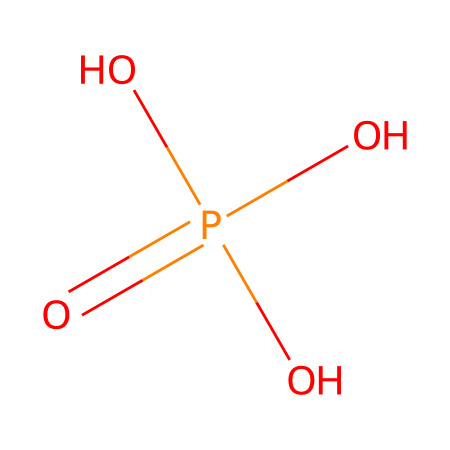What is the molecular formula of phosphoric acid? The SMILES representation shows the elements present in the structure: phosphorus (P) and oxygen (O), along with hydrogen (H). The counts are 1 phosphorus, 4 oxygen, and 3 hydrogen, leading to the formula H3PO4.
Answer: H3PO4 How many oxygen atoms are in this molecule? From the SMILES representation, we can count that there are four oxygen atoms connected to the phosphorus atom.
Answer: four What is the oxidation state of phosphorus in phosphoric acid? The oxidation state can be determined by assessing the bonds phosphorus forms in this molecule. Phosphorus is typically in the +5 oxidation state in phosphoric acid because it has bonded with four oxygen atoms.
Answer: +5 Which functional groups are present in phosphoric acid? Analyzing the structure shows that phosphoric acid contains hydroxyl (-OH) groups bonded to the phosphorus atom, identifying it as an alcohol and an acid, making it a polyprotic acid.
Answer: hydroxyl groups What type of chemical is phosphoric acid classified as? Phosphoric acid contains hydrogen, oxygen, and phosphorus and exhibits properties of an acid (as it can donate protons), specifically being categorized as a weak acid.
Answer: weak acid How many hydrogen atoms are directly bonded to the phosphorus atom? Examining the SMILES, we see that phosphoric acid has 3 hydrogen atoms directly bonded to three of the oxygen atoms, which indicates they are part of the hydroxyl groups.
Answer: three 